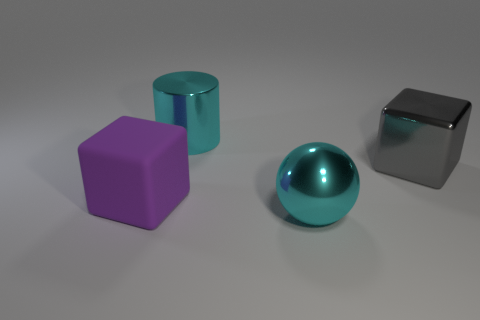Does the large sphere have the same material as the cube on the left side of the large ball? Upon examining the image, it seems that the large sphere does not share the same material as the cube on the left side. The sphere has a smooth, highly reflective surface with a consistent sheen, suggesting a polished, possibly metallic, material. In contrast, the cube has a dull finish with less pronounced reflections, which implies that it could be made of a matte material such as plastic. 